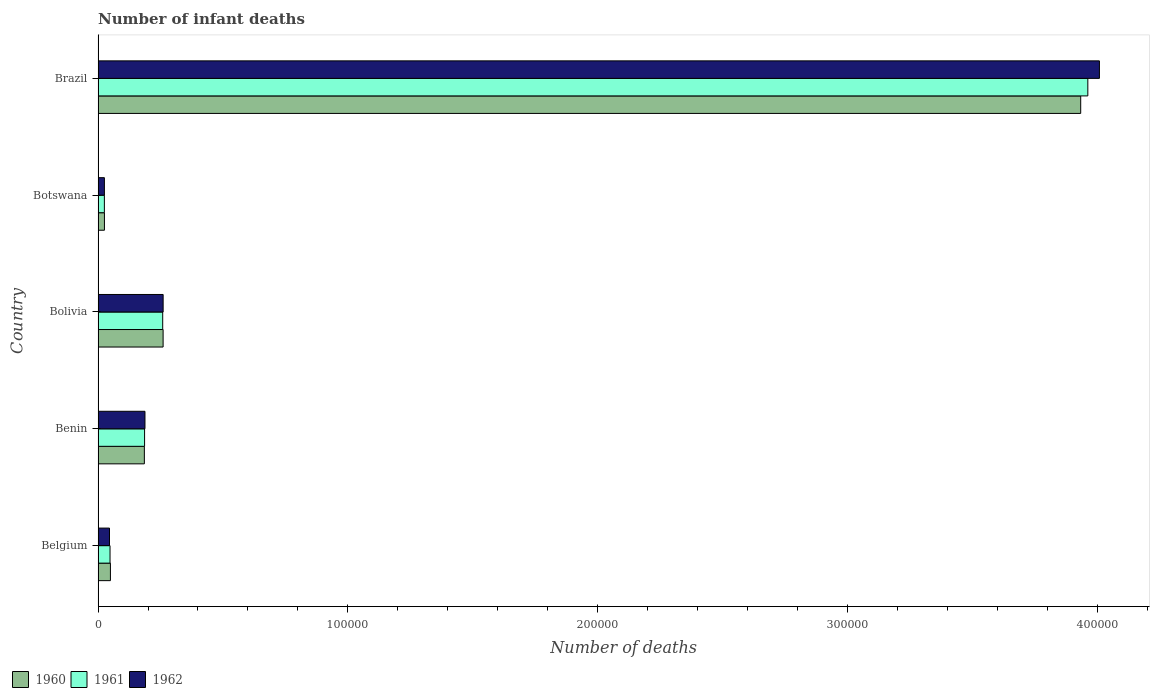Are the number of bars per tick equal to the number of legend labels?
Offer a very short reply. Yes. How many bars are there on the 5th tick from the top?
Provide a short and direct response. 3. What is the label of the 2nd group of bars from the top?
Your answer should be very brief. Botswana. What is the number of infant deaths in 1960 in Belgium?
Provide a short and direct response. 4942. Across all countries, what is the maximum number of infant deaths in 1962?
Give a very brief answer. 4.01e+05. Across all countries, what is the minimum number of infant deaths in 1962?
Ensure brevity in your answer.  2530. In which country was the number of infant deaths in 1961 minimum?
Provide a short and direct response. Botswana. What is the total number of infant deaths in 1962 in the graph?
Offer a very short reply. 4.53e+05. What is the difference between the number of infant deaths in 1961 in Benin and that in Botswana?
Ensure brevity in your answer.  1.61e+04. What is the difference between the number of infant deaths in 1961 in Brazil and the number of infant deaths in 1960 in Botswana?
Keep it short and to the point. 3.94e+05. What is the average number of infant deaths in 1961 per country?
Your answer should be very brief. 8.96e+04. In how many countries, is the number of infant deaths in 1960 greater than 160000 ?
Give a very brief answer. 1. What is the ratio of the number of infant deaths in 1961 in Belgium to that in Botswana?
Keep it short and to the point. 1.9. Is the number of infant deaths in 1962 in Benin less than that in Bolivia?
Provide a short and direct response. Yes. Is the difference between the number of infant deaths in 1961 in Benin and Botswana greater than the difference between the number of infant deaths in 1962 in Benin and Botswana?
Your answer should be very brief. No. What is the difference between the highest and the second highest number of infant deaths in 1960?
Your answer should be compact. 3.67e+05. What is the difference between the highest and the lowest number of infant deaths in 1961?
Give a very brief answer. 3.94e+05. In how many countries, is the number of infant deaths in 1961 greater than the average number of infant deaths in 1961 taken over all countries?
Your response must be concise. 1. What does the 3rd bar from the top in Brazil represents?
Keep it short and to the point. 1960. What does the 3rd bar from the bottom in Bolivia represents?
Ensure brevity in your answer.  1962. How many bars are there?
Keep it short and to the point. 15. How many countries are there in the graph?
Your answer should be compact. 5. What is the difference between two consecutive major ticks on the X-axis?
Ensure brevity in your answer.  1.00e+05. Are the values on the major ticks of X-axis written in scientific E-notation?
Ensure brevity in your answer.  No. Where does the legend appear in the graph?
Your response must be concise. Bottom left. What is the title of the graph?
Your response must be concise. Number of infant deaths. What is the label or title of the X-axis?
Your answer should be compact. Number of deaths. What is the Number of deaths in 1960 in Belgium?
Your answer should be very brief. 4942. What is the Number of deaths of 1961 in Belgium?
Your answer should be very brief. 4783. What is the Number of deaths in 1962 in Belgium?
Your answer should be very brief. 4571. What is the Number of deaths of 1960 in Benin?
Your answer should be compact. 1.85e+04. What is the Number of deaths in 1961 in Benin?
Your answer should be compact. 1.86e+04. What is the Number of deaths in 1962 in Benin?
Provide a short and direct response. 1.88e+04. What is the Number of deaths in 1960 in Bolivia?
Keep it short and to the point. 2.60e+04. What is the Number of deaths of 1961 in Bolivia?
Provide a short and direct response. 2.59e+04. What is the Number of deaths in 1962 in Bolivia?
Give a very brief answer. 2.60e+04. What is the Number of deaths in 1960 in Botswana?
Provide a succinct answer. 2546. What is the Number of deaths of 1961 in Botswana?
Offer a terse response. 2516. What is the Number of deaths in 1962 in Botswana?
Provide a short and direct response. 2530. What is the Number of deaths of 1960 in Brazil?
Keep it short and to the point. 3.93e+05. What is the Number of deaths of 1961 in Brazil?
Offer a very short reply. 3.96e+05. What is the Number of deaths in 1962 in Brazil?
Keep it short and to the point. 4.01e+05. Across all countries, what is the maximum Number of deaths of 1960?
Give a very brief answer. 3.93e+05. Across all countries, what is the maximum Number of deaths in 1961?
Your response must be concise. 3.96e+05. Across all countries, what is the maximum Number of deaths in 1962?
Your answer should be compact. 4.01e+05. Across all countries, what is the minimum Number of deaths in 1960?
Offer a very short reply. 2546. Across all countries, what is the minimum Number of deaths of 1961?
Keep it short and to the point. 2516. Across all countries, what is the minimum Number of deaths of 1962?
Keep it short and to the point. 2530. What is the total Number of deaths of 1960 in the graph?
Ensure brevity in your answer.  4.45e+05. What is the total Number of deaths of 1961 in the graph?
Your answer should be compact. 4.48e+05. What is the total Number of deaths in 1962 in the graph?
Ensure brevity in your answer.  4.53e+05. What is the difference between the Number of deaths of 1960 in Belgium and that in Benin?
Keep it short and to the point. -1.36e+04. What is the difference between the Number of deaths of 1961 in Belgium and that in Benin?
Your answer should be compact. -1.38e+04. What is the difference between the Number of deaths in 1962 in Belgium and that in Benin?
Your answer should be very brief. -1.42e+04. What is the difference between the Number of deaths of 1960 in Belgium and that in Bolivia?
Provide a short and direct response. -2.11e+04. What is the difference between the Number of deaths in 1961 in Belgium and that in Bolivia?
Give a very brief answer. -2.11e+04. What is the difference between the Number of deaths in 1962 in Belgium and that in Bolivia?
Give a very brief answer. -2.15e+04. What is the difference between the Number of deaths of 1960 in Belgium and that in Botswana?
Keep it short and to the point. 2396. What is the difference between the Number of deaths in 1961 in Belgium and that in Botswana?
Provide a short and direct response. 2267. What is the difference between the Number of deaths of 1962 in Belgium and that in Botswana?
Provide a short and direct response. 2041. What is the difference between the Number of deaths in 1960 in Belgium and that in Brazil?
Your answer should be very brief. -3.88e+05. What is the difference between the Number of deaths of 1961 in Belgium and that in Brazil?
Your answer should be compact. -3.91e+05. What is the difference between the Number of deaths in 1962 in Belgium and that in Brazil?
Make the answer very short. -3.96e+05. What is the difference between the Number of deaths in 1960 in Benin and that in Bolivia?
Your response must be concise. -7506. What is the difference between the Number of deaths of 1961 in Benin and that in Bolivia?
Provide a short and direct response. -7255. What is the difference between the Number of deaths of 1962 in Benin and that in Bolivia?
Offer a very short reply. -7273. What is the difference between the Number of deaths in 1960 in Benin and that in Botswana?
Keep it short and to the point. 1.60e+04. What is the difference between the Number of deaths of 1961 in Benin and that in Botswana?
Your answer should be compact. 1.61e+04. What is the difference between the Number of deaths of 1962 in Benin and that in Botswana?
Ensure brevity in your answer.  1.62e+04. What is the difference between the Number of deaths in 1960 in Benin and that in Brazil?
Your response must be concise. -3.75e+05. What is the difference between the Number of deaths of 1961 in Benin and that in Brazil?
Offer a very short reply. -3.78e+05. What is the difference between the Number of deaths of 1962 in Benin and that in Brazil?
Offer a terse response. -3.82e+05. What is the difference between the Number of deaths of 1960 in Bolivia and that in Botswana?
Your answer should be very brief. 2.35e+04. What is the difference between the Number of deaths of 1961 in Bolivia and that in Botswana?
Your answer should be very brief. 2.34e+04. What is the difference between the Number of deaths of 1962 in Bolivia and that in Botswana?
Your response must be concise. 2.35e+04. What is the difference between the Number of deaths of 1960 in Bolivia and that in Brazil?
Your answer should be very brief. -3.67e+05. What is the difference between the Number of deaths of 1961 in Bolivia and that in Brazil?
Your answer should be compact. -3.70e+05. What is the difference between the Number of deaths in 1962 in Bolivia and that in Brazil?
Your response must be concise. -3.75e+05. What is the difference between the Number of deaths of 1960 in Botswana and that in Brazil?
Offer a terse response. -3.91e+05. What is the difference between the Number of deaths in 1961 in Botswana and that in Brazil?
Provide a succinct answer. -3.94e+05. What is the difference between the Number of deaths of 1962 in Botswana and that in Brazil?
Offer a terse response. -3.98e+05. What is the difference between the Number of deaths of 1960 in Belgium and the Number of deaths of 1961 in Benin?
Offer a terse response. -1.37e+04. What is the difference between the Number of deaths of 1960 in Belgium and the Number of deaths of 1962 in Benin?
Give a very brief answer. -1.38e+04. What is the difference between the Number of deaths of 1961 in Belgium and the Number of deaths of 1962 in Benin?
Make the answer very short. -1.40e+04. What is the difference between the Number of deaths of 1960 in Belgium and the Number of deaths of 1961 in Bolivia?
Keep it short and to the point. -2.09e+04. What is the difference between the Number of deaths in 1960 in Belgium and the Number of deaths in 1962 in Bolivia?
Your answer should be very brief. -2.11e+04. What is the difference between the Number of deaths in 1961 in Belgium and the Number of deaths in 1962 in Bolivia?
Ensure brevity in your answer.  -2.13e+04. What is the difference between the Number of deaths of 1960 in Belgium and the Number of deaths of 1961 in Botswana?
Your response must be concise. 2426. What is the difference between the Number of deaths of 1960 in Belgium and the Number of deaths of 1962 in Botswana?
Provide a succinct answer. 2412. What is the difference between the Number of deaths in 1961 in Belgium and the Number of deaths in 1962 in Botswana?
Ensure brevity in your answer.  2253. What is the difference between the Number of deaths of 1960 in Belgium and the Number of deaths of 1961 in Brazil?
Make the answer very short. -3.91e+05. What is the difference between the Number of deaths in 1960 in Belgium and the Number of deaths in 1962 in Brazil?
Offer a very short reply. -3.96e+05. What is the difference between the Number of deaths of 1961 in Belgium and the Number of deaths of 1962 in Brazil?
Your answer should be very brief. -3.96e+05. What is the difference between the Number of deaths of 1960 in Benin and the Number of deaths of 1961 in Bolivia?
Provide a short and direct response. -7342. What is the difference between the Number of deaths of 1960 in Benin and the Number of deaths of 1962 in Bolivia?
Your answer should be very brief. -7515. What is the difference between the Number of deaths in 1961 in Benin and the Number of deaths in 1962 in Bolivia?
Make the answer very short. -7428. What is the difference between the Number of deaths of 1960 in Benin and the Number of deaths of 1961 in Botswana?
Give a very brief answer. 1.60e+04. What is the difference between the Number of deaths of 1960 in Benin and the Number of deaths of 1962 in Botswana?
Provide a short and direct response. 1.60e+04. What is the difference between the Number of deaths of 1961 in Benin and the Number of deaths of 1962 in Botswana?
Keep it short and to the point. 1.61e+04. What is the difference between the Number of deaths in 1960 in Benin and the Number of deaths in 1961 in Brazil?
Your response must be concise. -3.78e+05. What is the difference between the Number of deaths in 1960 in Benin and the Number of deaths in 1962 in Brazil?
Provide a succinct answer. -3.82e+05. What is the difference between the Number of deaths of 1961 in Benin and the Number of deaths of 1962 in Brazil?
Keep it short and to the point. -3.82e+05. What is the difference between the Number of deaths in 1960 in Bolivia and the Number of deaths in 1961 in Botswana?
Your answer should be compact. 2.35e+04. What is the difference between the Number of deaths in 1960 in Bolivia and the Number of deaths in 1962 in Botswana?
Keep it short and to the point. 2.35e+04. What is the difference between the Number of deaths of 1961 in Bolivia and the Number of deaths of 1962 in Botswana?
Offer a very short reply. 2.33e+04. What is the difference between the Number of deaths in 1960 in Bolivia and the Number of deaths in 1961 in Brazil?
Keep it short and to the point. -3.70e+05. What is the difference between the Number of deaths in 1960 in Bolivia and the Number of deaths in 1962 in Brazil?
Keep it short and to the point. -3.75e+05. What is the difference between the Number of deaths in 1961 in Bolivia and the Number of deaths in 1962 in Brazil?
Your answer should be compact. -3.75e+05. What is the difference between the Number of deaths in 1960 in Botswana and the Number of deaths in 1961 in Brazil?
Offer a terse response. -3.94e+05. What is the difference between the Number of deaths in 1960 in Botswana and the Number of deaths in 1962 in Brazil?
Give a very brief answer. -3.98e+05. What is the difference between the Number of deaths of 1961 in Botswana and the Number of deaths of 1962 in Brazil?
Your answer should be very brief. -3.98e+05. What is the average Number of deaths in 1960 per country?
Your response must be concise. 8.91e+04. What is the average Number of deaths of 1961 per country?
Your answer should be very brief. 8.96e+04. What is the average Number of deaths in 1962 per country?
Your answer should be compact. 9.06e+04. What is the difference between the Number of deaths in 1960 and Number of deaths in 1961 in Belgium?
Offer a very short reply. 159. What is the difference between the Number of deaths of 1960 and Number of deaths of 1962 in Belgium?
Your answer should be compact. 371. What is the difference between the Number of deaths of 1961 and Number of deaths of 1962 in Belgium?
Make the answer very short. 212. What is the difference between the Number of deaths of 1960 and Number of deaths of 1961 in Benin?
Provide a succinct answer. -87. What is the difference between the Number of deaths in 1960 and Number of deaths in 1962 in Benin?
Give a very brief answer. -242. What is the difference between the Number of deaths of 1961 and Number of deaths of 1962 in Benin?
Provide a succinct answer. -155. What is the difference between the Number of deaths in 1960 and Number of deaths in 1961 in Bolivia?
Ensure brevity in your answer.  164. What is the difference between the Number of deaths of 1960 and Number of deaths of 1962 in Bolivia?
Give a very brief answer. -9. What is the difference between the Number of deaths of 1961 and Number of deaths of 1962 in Bolivia?
Your answer should be compact. -173. What is the difference between the Number of deaths in 1960 and Number of deaths in 1961 in Botswana?
Ensure brevity in your answer.  30. What is the difference between the Number of deaths in 1960 and Number of deaths in 1961 in Brazil?
Offer a terse response. -2856. What is the difference between the Number of deaths of 1960 and Number of deaths of 1962 in Brazil?
Give a very brief answer. -7497. What is the difference between the Number of deaths of 1961 and Number of deaths of 1962 in Brazil?
Ensure brevity in your answer.  -4641. What is the ratio of the Number of deaths of 1960 in Belgium to that in Benin?
Offer a terse response. 0.27. What is the ratio of the Number of deaths in 1961 in Belgium to that in Benin?
Your answer should be very brief. 0.26. What is the ratio of the Number of deaths of 1962 in Belgium to that in Benin?
Give a very brief answer. 0.24. What is the ratio of the Number of deaths in 1960 in Belgium to that in Bolivia?
Offer a very short reply. 0.19. What is the ratio of the Number of deaths in 1961 in Belgium to that in Bolivia?
Keep it short and to the point. 0.18. What is the ratio of the Number of deaths of 1962 in Belgium to that in Bolivia?
Your answer should be compact. 0.18. What is the ratio of the Number of deaths of 1960 in Belgium to that in Botswana?
Ensure brevity in your answer.  1.94. What is the ratio of the Number of deaths in 1961 in Belgium to that in Botswana?
Your answer should be compact. 1.9. What is the ratio of the Number of deaths in 1962 in Belgium to that in Botswana?
Your answer should be very brief. 1.81. What is the ratio of the Number of deaths in 1960 in Belgium to that in Brazil?
Make the answer very short. 0.01. What is the ratio of the Number of deaths in 1961 in Belgium to that in Brazil?
Provide a short and direct response. 0.01. What is the ratio of the Number of deaths in 1962 in Belgium to that in Brazil?
Offer a terse response. 0.01. What is the ratio of the Number of deaths of 1960 in Benin to that in Bolivia?
Offer a terse response. 0.71. What is the ratio of the Number of deaths in 1961 in Benin to that in Bolivia?
Give a very brief answer. 0.72. What is the ratio of the Number of deaths of 1962 in Benin to that in Bolivia?
Make the answer very short. 0.72. What is the ratio of the Number of deaths of 1960 in Benin to that in Botswana?
Offer a very short reply. 7.28. What is the ratio of the Number of deaths of 1961 in Benin to that in Botswana?
Offer a very short reply. 7.4. What is the ratio of the Number of deaths in 1962 in Benin to that in Botswana?
Keep it short and to the point. 7.42. What is the ratio of the Number of deaths in 1960 in Benin to that in Brazil?
Provide a short and direct response. 0.05. What is the ratio of the Number of deaths in 1961 in Benin to that in Brazil?
Ensure brevity in your answer.  0.05. What is the ratio of the Number of deaths in 1962 in Benin to that in Brazil?
Offer a very short reply. 0.05. What is the ratio of the Number of deaths in 1960 in Bolivia to that in Botswana?
Make the answer very short. 10.23. What is the ratio of the Number of deaths of 1961 in Bolivia to that in Botswana?
Offer a terse response. 10.28. What is the ratio of the Number of deaths of 1962 in Bolivia to that in Botswana?
Offer a terse response. 10.29. What is the ratio of the Number of deaths of 1960 in Bolivia to that in Brazil?
Your response must be concise. 0.07. What is the ratio of the Number of deaths of 1961 in Bolivia to that in Brazil?
Ensure brevity in your answer.  0.07. What is the ratio of the Number of deaths of 1962 in Bolivia to that in Brazil?
Provide a succinct answer. 0.07. What is the ratio of the Number of deaths of 1960 in Botswana to that in Brazil?
Give a very brief answer. 0.01. What is the ratio of the Number of deaths in 1961 in Botswana to that in Brazil?
Your answer should be compact. 0.01. What is the ratio of the Number of deaths of 1962 in Botswana to that in Brazil?
Provide a short and direct response. 0.01. What is the difference between the highest and the second highest Number of deaths of 1960?
Offer a terse response. 3.67e+05. What is the difference between the highest and the second highest Number of deaths of 1961?
Your answer should be compact. 3.70e+05. What is the difference between the highest and the second highest Number of deaths of 1962?
Keep it short and to the point. 3.75e+05. What is the difference between the highest and the lowest Number of deaths of 1960?
Provide a short and direct response. 3.91e+05. What is the difference between the highest and the lowest Number of deaths of 1961?
Offer a very short reply. 3.94e+05. What is the difference between the highest and the lowest Number of deaths of 1962?
Your response must be concise. 3.98e+05. 